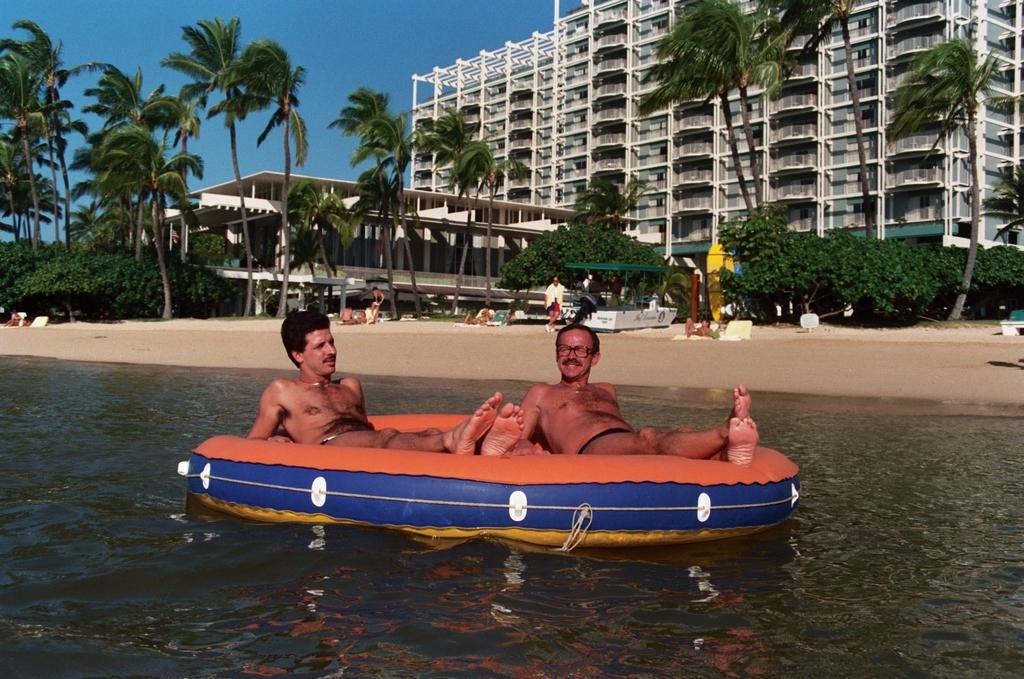How many people are in the image? There are people in the image, specifically two people lying on an inflatable swim step. What is the swim step resting on? The swim step is on the ocean. What can be seen in the background of the image? Buildings, trees, and plants are visible in the image. What part of the natural environment is visible in the image? The sky is visible in the image. What type of pollution can be seen in the image? There is no pollution visible in the image. How does the distribution of people on the swim step affect the flight of nearby birds? There are no birds mentioned in the image, so it is not possible to determine the effect of the people on the swim step on their flight. 